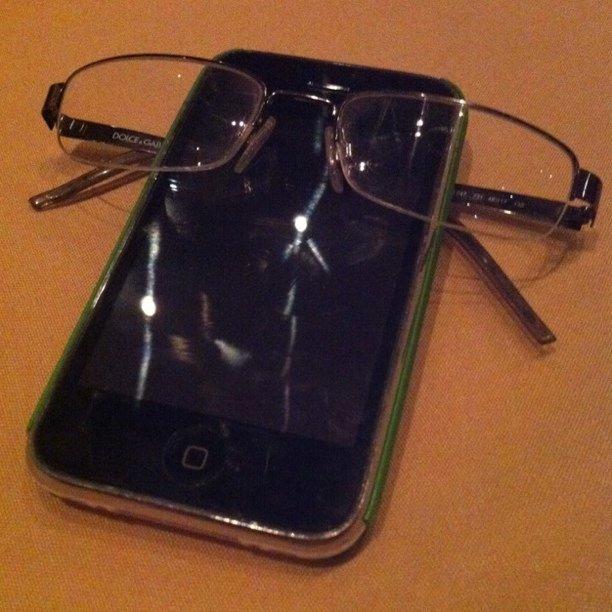What brand is the device?
Keep it brief. Apple. Who makes this cell phone?
Give a very brief answer. Apple. What color is the table?
Keep it brief. Brown. Is this a smartphone?
Quick response, please. Yes. Where is the phone sitting?
Give a very brief answer. Table. Are there colors visible?
Concise answer only. Yes. 